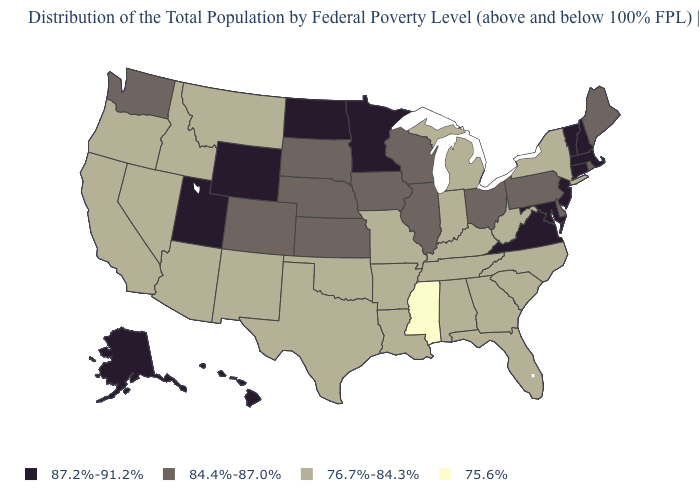What is the lowest value in states that border Tennessee?
Be succinct. 75.6%. Name the states that have a value in the range 76.7%-84.3%?
Keep it brief. Alabama, Arizona, Arkansas, California, Florida, Georgia, Idaho, Indiana, Kentucky, Louisiana, Michigan, Missouri, Montana, Nevada, New Mexico, New York, North Carolina, Oklahoma, Oregon, South Carolina, Tennessee, Texas, West Virginia. What is the value of Massachusetts?
Give a very brief answer. 87.2%-91.2%. What is the value of Mississippi?
Quick response, please. 75.6%. What is the value of South Carolina?
Write a very short answer. 76.7%-84.3%. Does Wyoming have a higher value than Tennessee?
Quick response, please. Yes. Does Oregon have the same value as Alabama?
Answer briefly. Yes. Which states have the highest value in the USA?
Short answer required. Alaska, Connecticut, Hawaii, Maryland, Massachusetts, Minnesota, New Hampshire, New Jersey, North Dakota, Utah, Vermont, Virginia, Wyoming. Name the states that have a value in the range 75.6%?
Keep it brief. Mississippi. Does Hawaii have the same value as Connecticut?
Concise answer only. Yes. What is the value of Arkansas?
Quick response, please. 76.7%-84.3%. Name the states that have a value in the range 75.6%?
Short answer required. Mississippi. Does Maryland have the highest value in the USA?
Keep it brief. Yes. What is the lowest value in states that border North Dakota?
Answer briefly. 76.7%-84.3%. Name the states that have a value in the range 76.7%-84.3%?
Give a very brief answer. Alabama, Arizona, Arkansas, California, Florida, Georgia, Idaho, Indiana, Kentucky, Louisiana, Michigan, Missouri, Montana, Nevada, New Mexico, New York, North Carolina, Oklahoma, Oregon, South Carolina, Tennessee, Texas, West Virginia. 